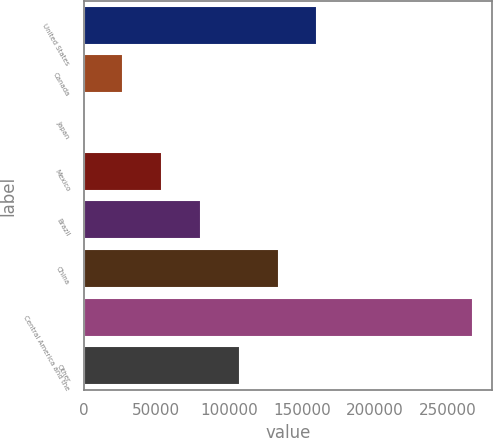<chart> <loc_0><loc_0><loc_500><loc_500><bar_chart><fcel>United States<fcel>Canada<fcel>Japan<fcel>Mexico<fcel>Brazil<fcel>China<fcel>Central America and the<fcel>Other<nl><fcel>160591<fcel>27234.4<fcel>563<fcel>53905.8<fcel>80577.2<fcel>133920<fcel>267277<fcel>107249<nl></chart> 